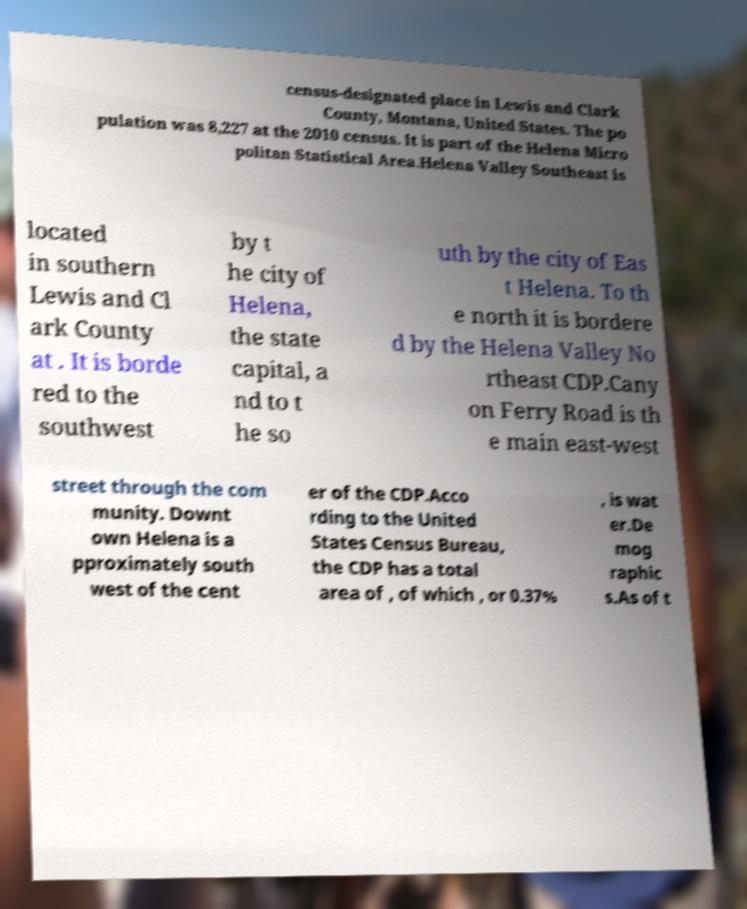Could you assist in decoding the text presented in this image and type it out clearly? census-designated place in Lewis and Clark County, Montana, United States. The po pulation was 8,227 at the 2010 census. It is part of the Helena Micro politan Statistical Area.Helena Valley Southeast is located in southern Lewis and Cl ark County at . It is borde red to the southwest by t he city of Helena, the state capital, a nd to t he so uth by the city of Eas t Helena. To th e north it is bordere d by the Helena Valley No rtheast CDP.Cany on Ferry Road is th e main east-west street through the com munity. Downt own Helena is a pproximately south west of the cent er of the CDP.Acco rding to the United States Census Bureau, the CDP has a total area of , of which , or 0.37% , is wat er.De mog raphic s.As of t 